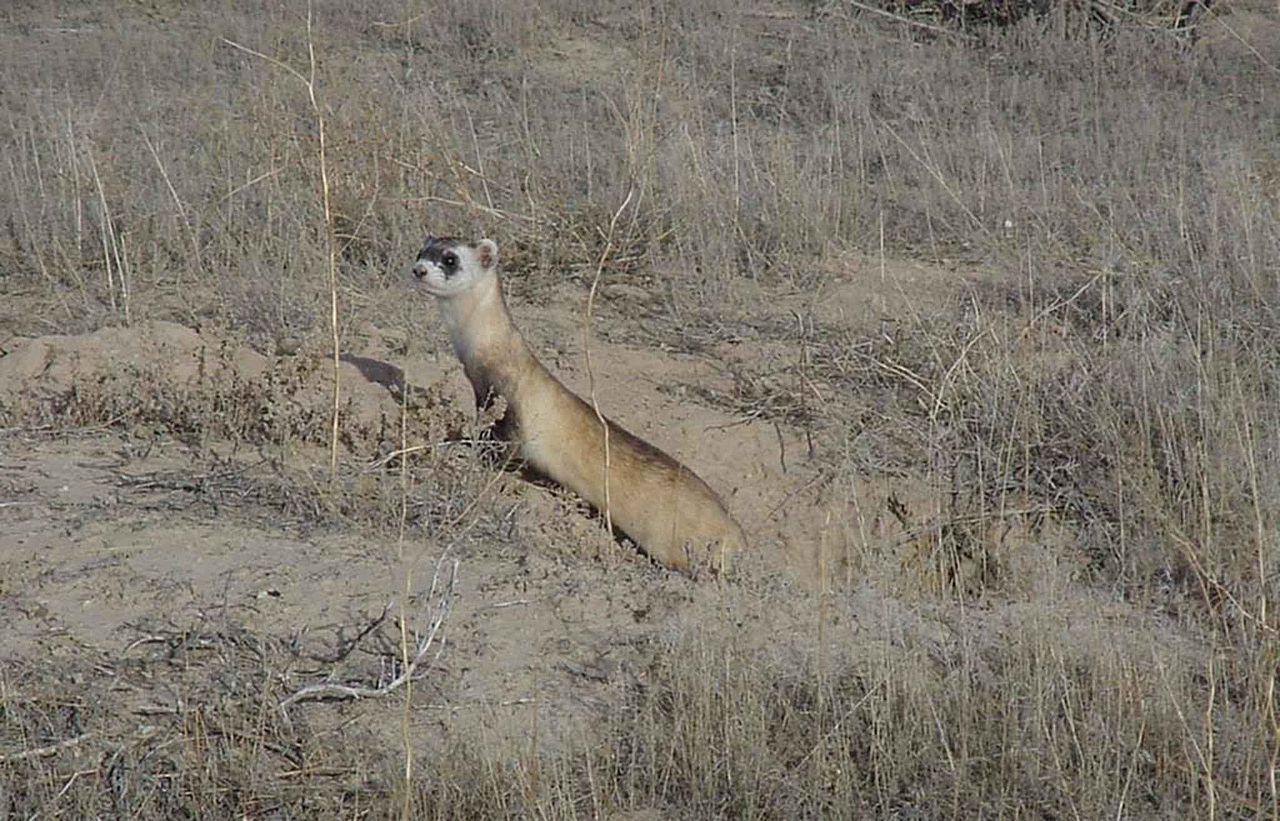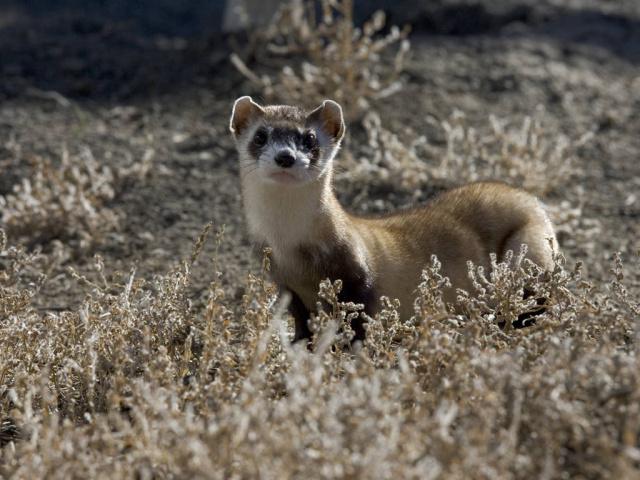The first image is the image on the left, the second image is the image on the right. Analyze the images presented: Is the assertion "At least one ferret is emerging from a hole and looking in the distance." valid? Answer yes or no. Yes. The first image is the image on the left, the second image is the image on the right. Assess this claim about the two images: "In the image on the right, a small portion of the ferret's body is occluded by some of the grass.". Correct or not? Answer yes or no. Yes. 